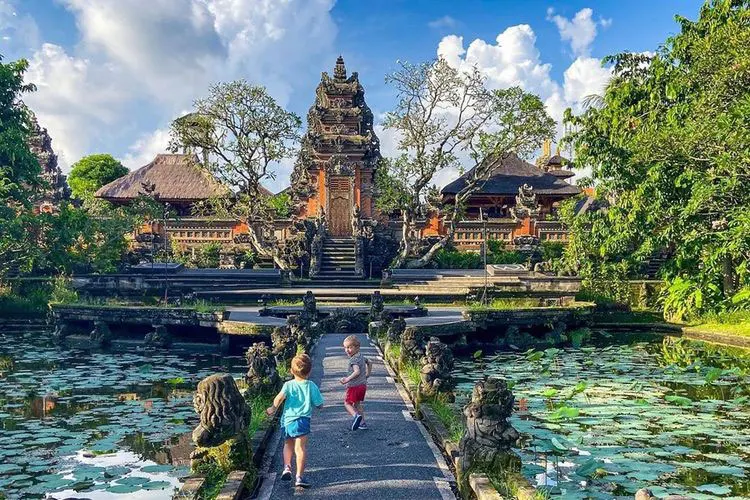Can you tell me more about the architectural style of this palace? Certainly! The architectural style of the Ubud Water Palace is predominantly Balinese, which integrates Hindu-Javanese elements. The structures often feature intricate carvings and statues, red brick construction, and a tiered roof that is distinctly characteristic of Balinese temples, known as 'Meru'. The design elements are not only aesthetically pleasing but also serve religious and cultural purposes, symbolizing a connection to the divine. 